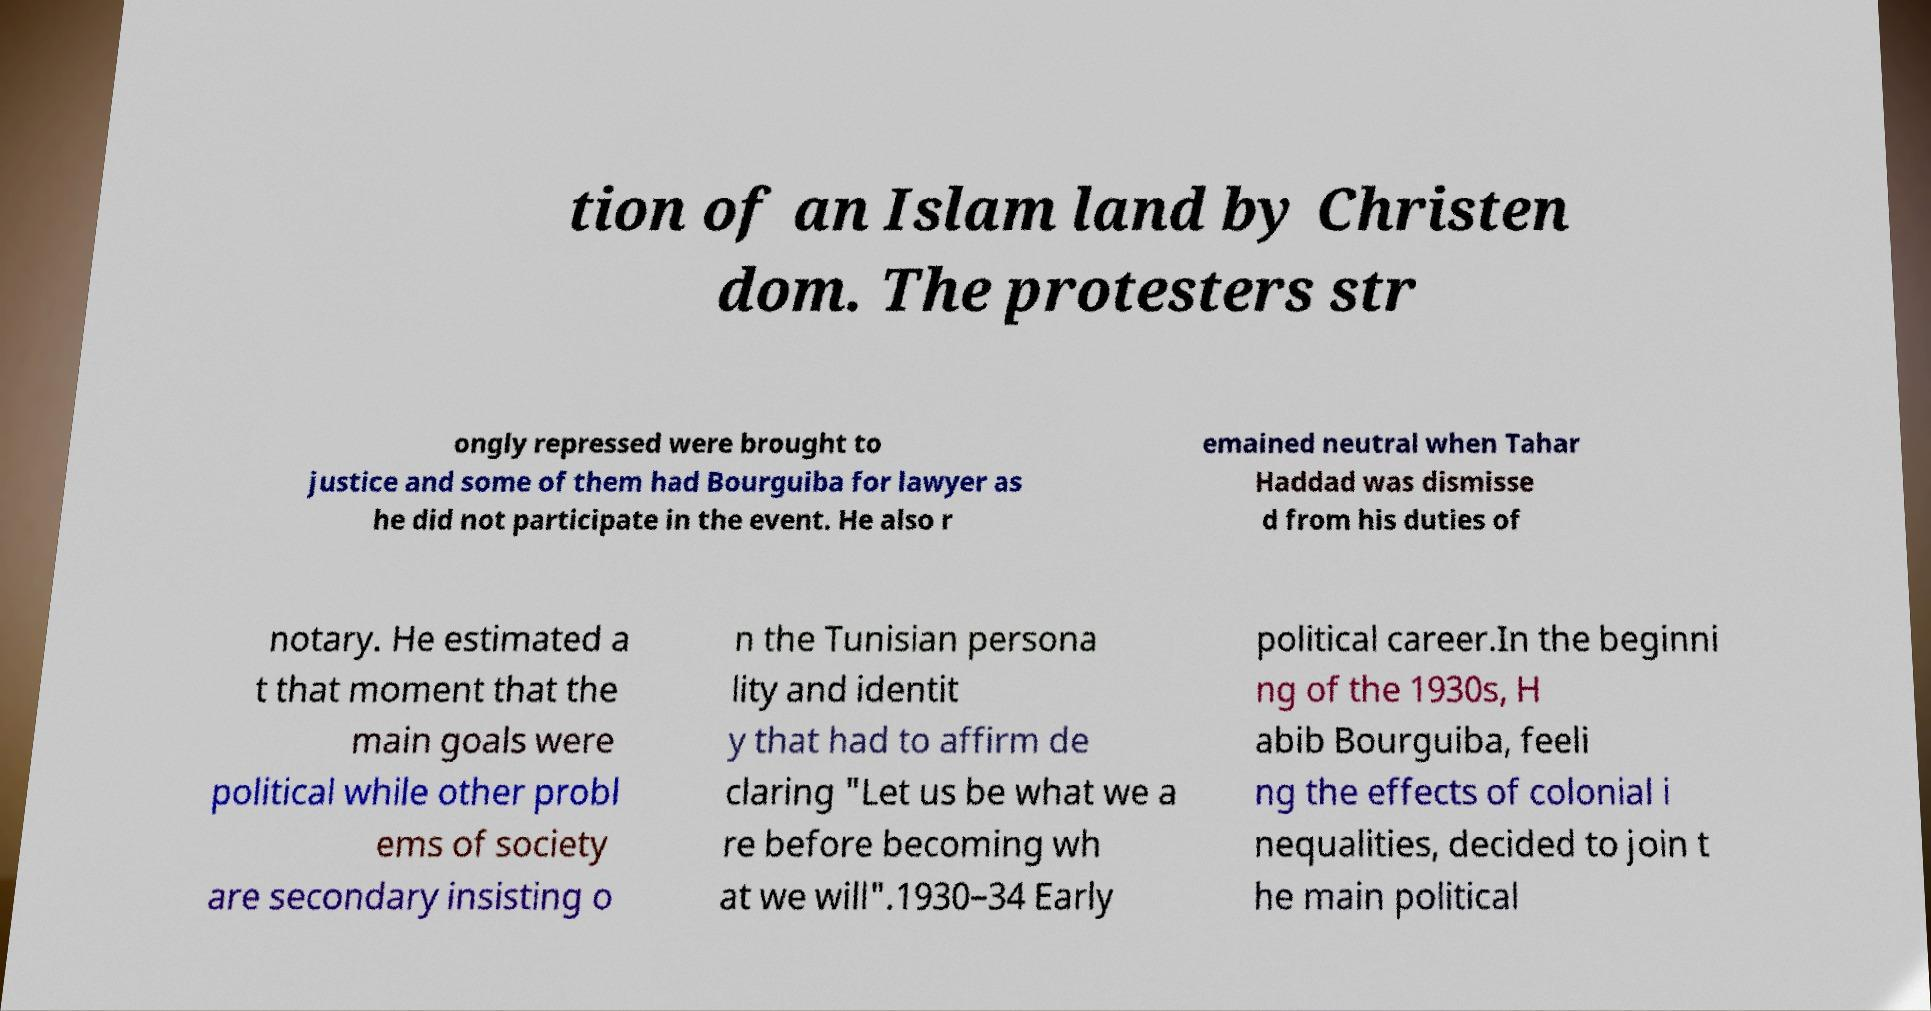Can you accurately transcribe the text from the provided image for me? tion of an Islam land by Christen dom. The protesters str ongly repressed were brought to justice and some of them had Bourguiba for lawyer as he did not participate in the event. He also r emained neutral when Tahar Haddad was dismisse d from his duties of notary. He estimated a t that moment that the main goals were political while other probl ems of society are secondary insisting o n the Tunisian persona lity and identit y that had to affirm de claring "Let us be what we a re before becoming wh at we will".1930–34 Early political career.In the beginni ng of the 1930s, H abib Bourguiba, feeli ng the effects of colonial i nequalities, decided to join t he main political 